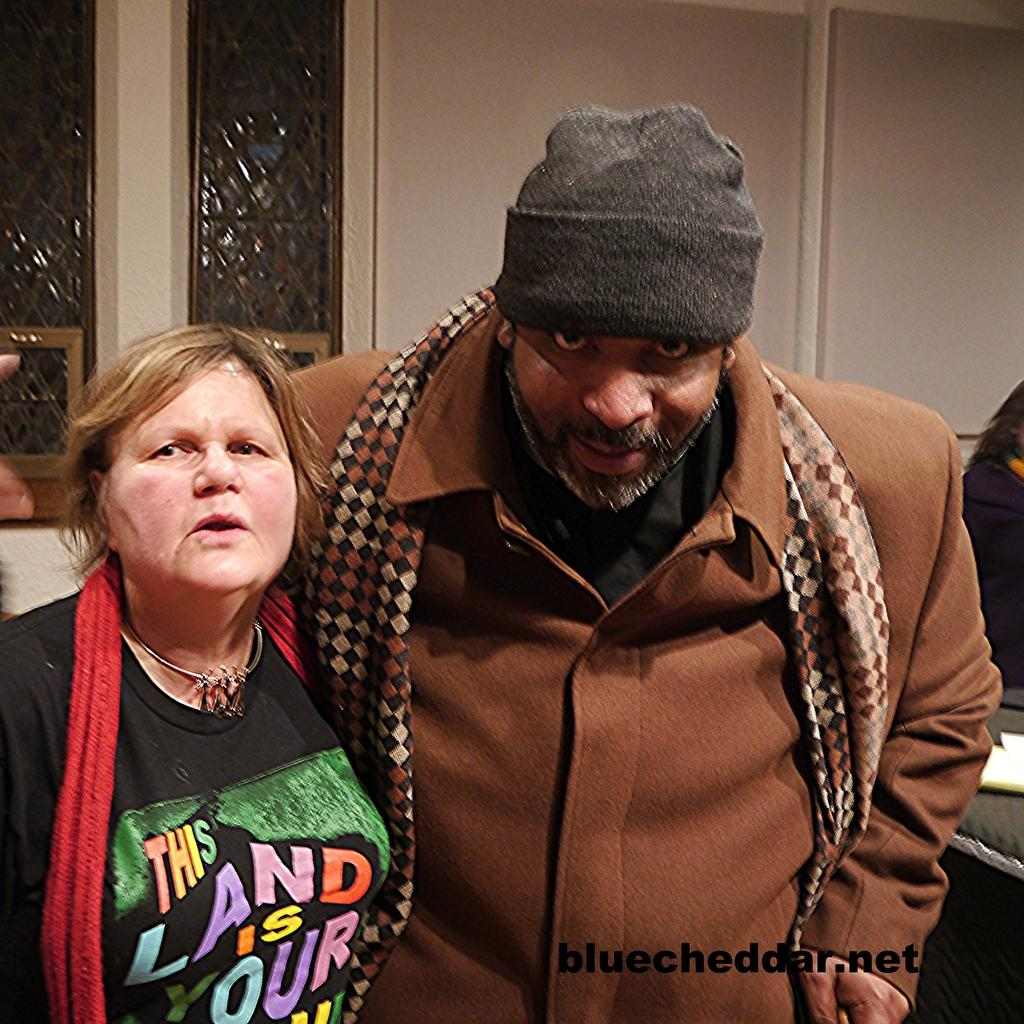How many people are in the foreground of the picture? There are two people, a man and a woman, in the foreground of the picture. What are the man and woman doing in the picture? The man and woman are standing in the foreground of the picture. What can be seen in the background of the picture? There are windows, a wall, at least one person, and other objects in the background of the picture. What type of dinosaur can be seen in the background of the picture? There are no dinosaurs present in the image; it features a man and a woman standing in the foreground, with windows, a wall, and other objects in the background. What kind of doll is sitting on the windowsill in the picture? There is no doll present in the image; it only features a man and a woman standing in the foreground, with windows, a wall, and other objects in the background. 